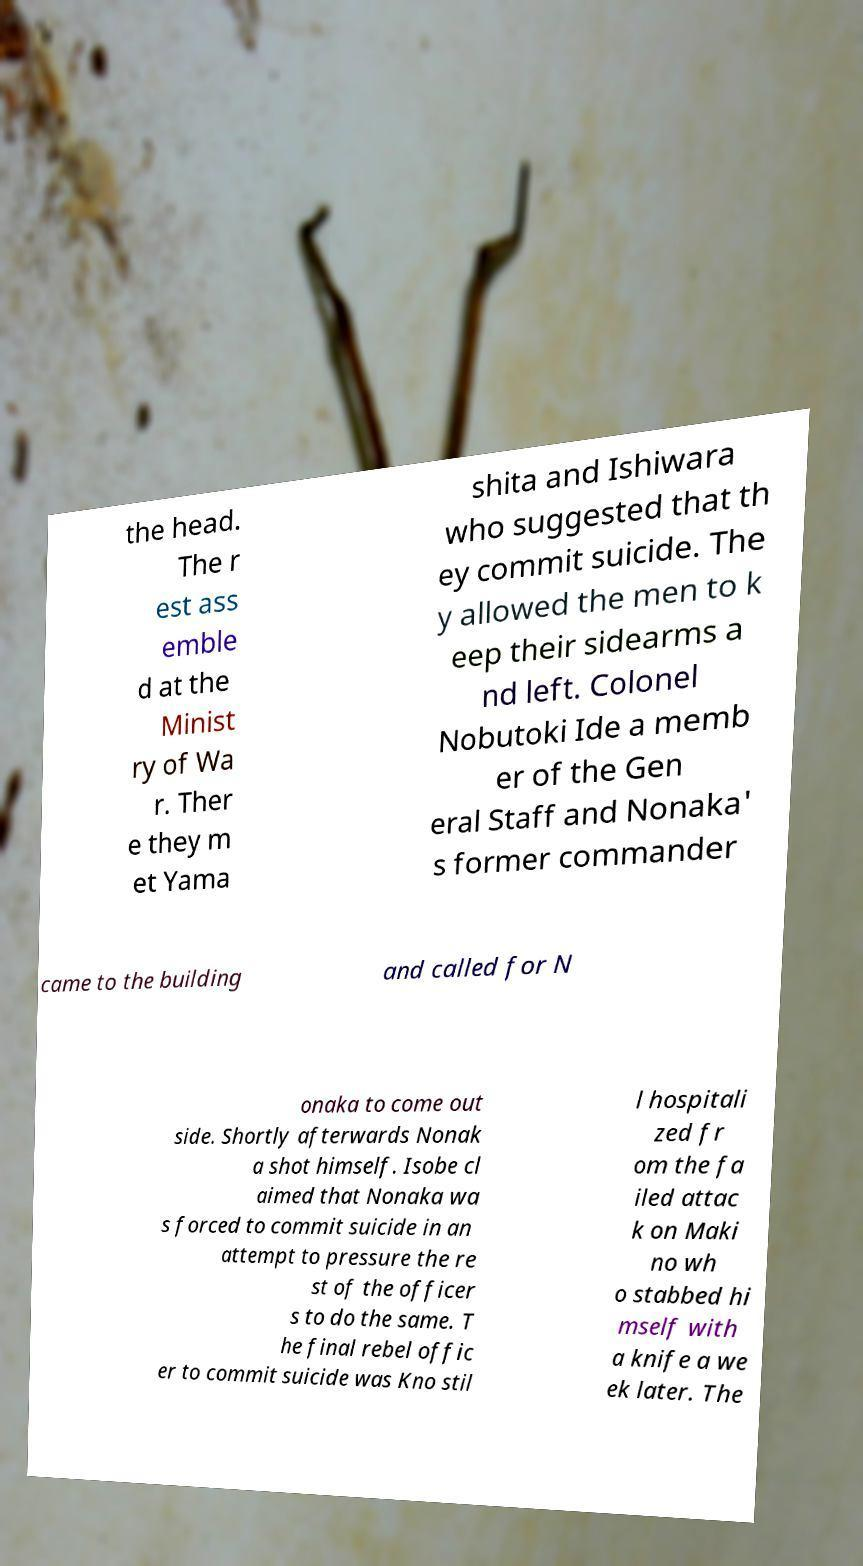Could you assist in decoding the text presented in this image and type it out clearly? the head. The r est ass emble d at the Minist ry of Wa r. Ther e they m et Yama shita and Ishiwara who suggested that th ey commit suicide. The y allowed the men to k eep their sidearms a nd left. Colonel Nobutoki Ide a memb er of the Gen eral Staff and Nonaka' s former commander came to the building and called for N onaka to come out side. Shortly afterwards Nonak a shot himself. Isobe cl aimed that Nonaka wa s forced to commit suicide in an attempt to pressure the re st of the officer s to do the same. T he final rebel offic er to commit suicide was Kno stil l hospitali zed fr om the fa iled attac k on Maki no wh o stabbed hi mself with a knife a we ek later. The 